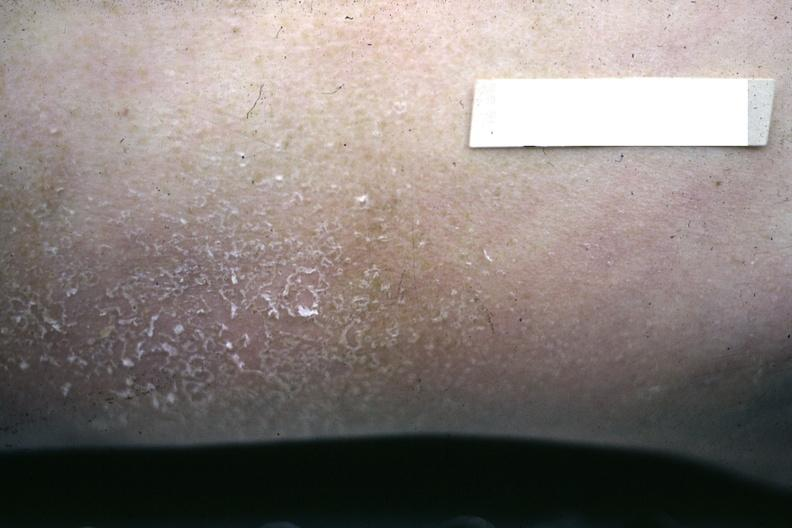s uremic frost present?
Answer the question using a single word or phrase. Yes 